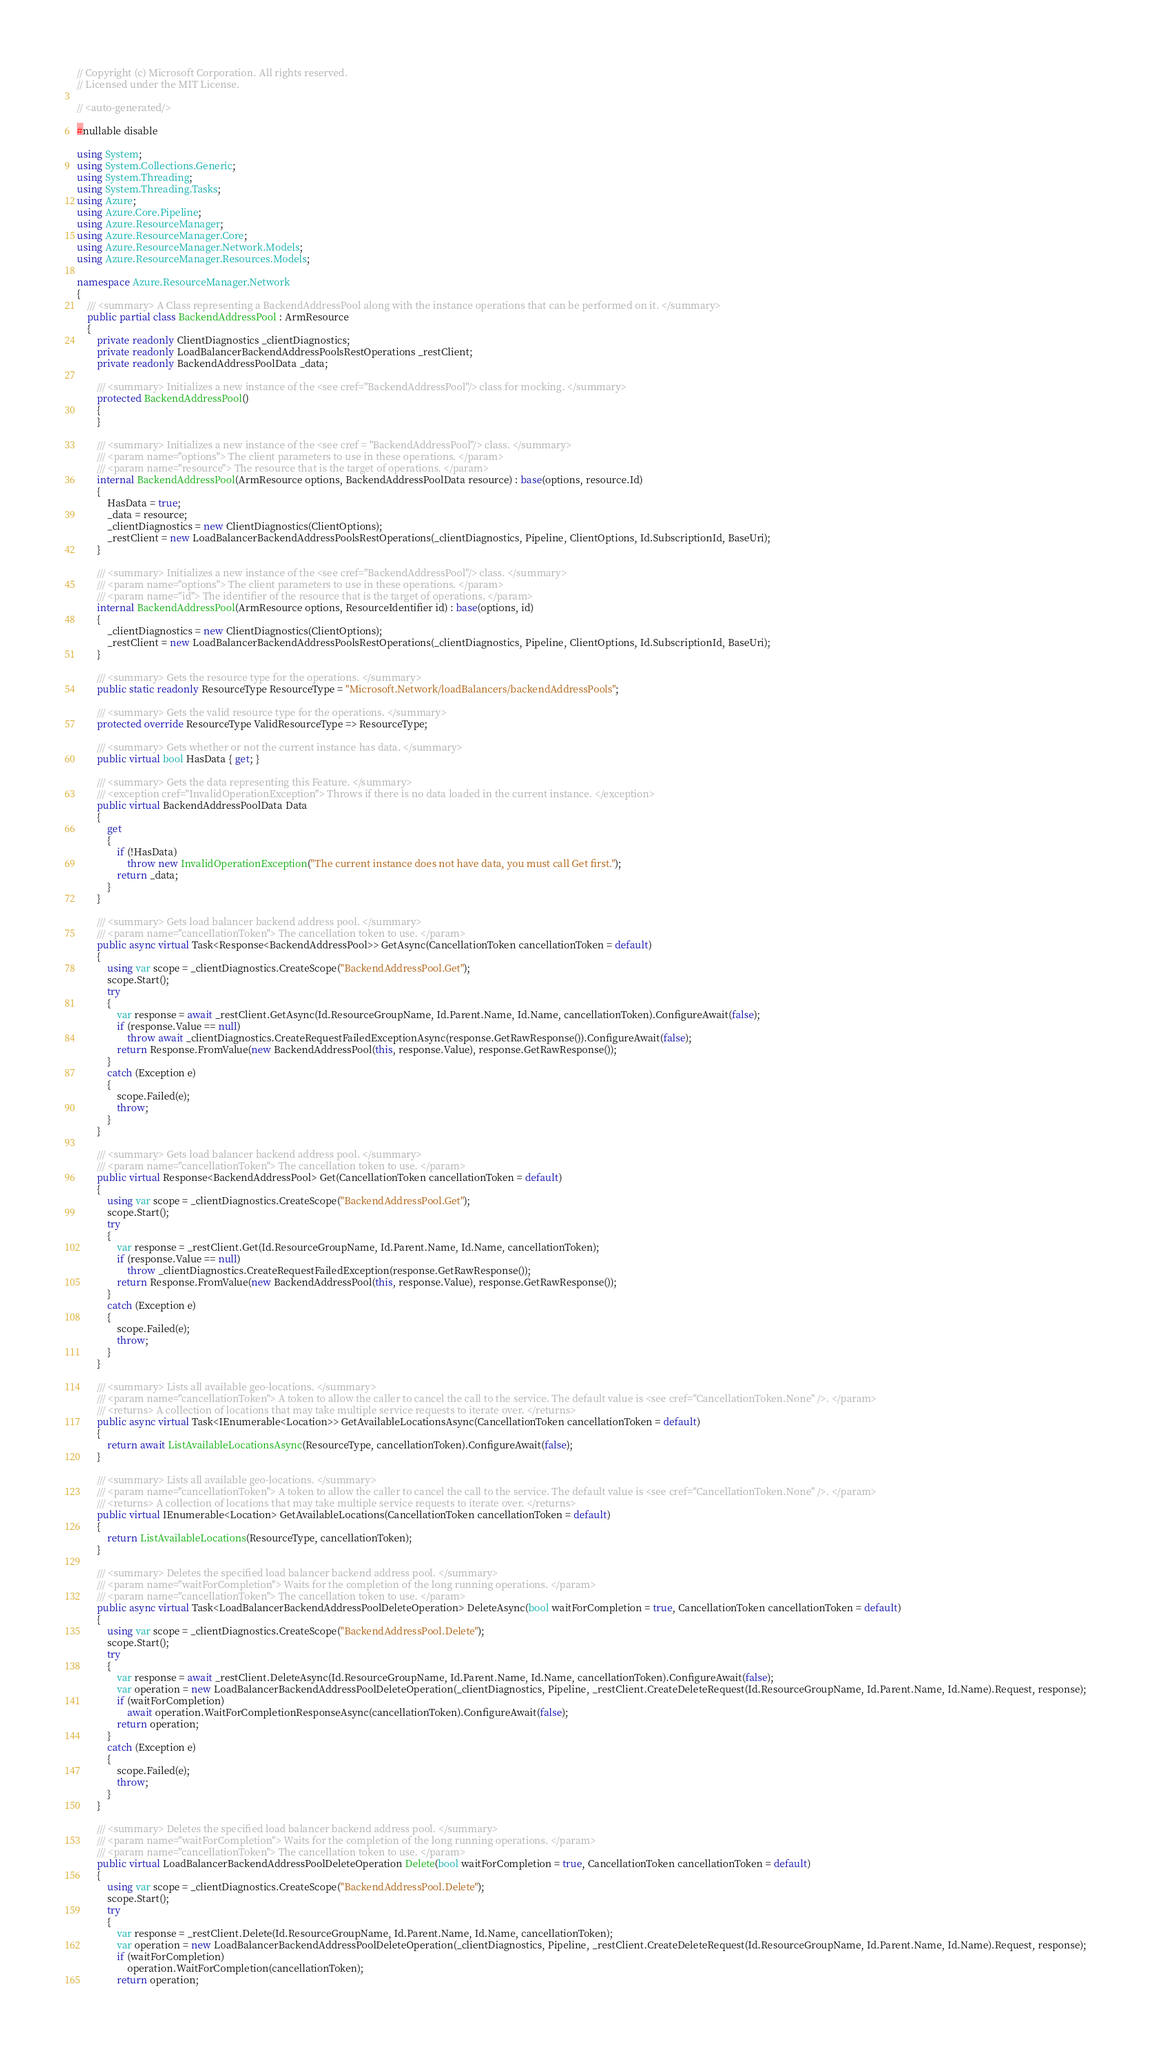Convert code to text. <code><loc_0><loc_0><loc_500><loc_500><_C#_>// Copyright (c) Microsoft Corporation. All rights reserved.
// Licensed under the MIT License.

// <auto-generated/>

#nullable disable

using System;
using System.Collections.Generic;
using System.Threading;
using System.Threading.Tasks;
using Azure;
using Azure.Core.Pipeline;
using Azure.ResourceManager;
using Azure.ResourceManager.Core;
using Azure.ResourceManager.Network.Models;
using Azure.ResourceManager.Resources.Models;

namespace Azure.ResourceManager.Network
{
    /// <summary> A Class representing a BackendAddressPool along with the instance operations that can be performed on it. </summary>
    public partial class BackendAddressPool : ArmResource
    {
        private readonly ClientDiagnostics _clientDiagnostics;
        private readonly LoadBalancerBackendAddressPoolsRestOperations _restClient;
        private readonly BackendAddressPoolData _data;

        /// <summary> Initializes a new instance of the <see cref="BackendAddressPool"/> class for mocking. </summary>
        protected BackendAddressPool()
        {
        }

        /// <summary> Initializes a new instance of the <see cref = "BackendAddressPool"/> class. </summary>
        /// <param name="options"> The client parameters to use in these operations. </param>
        /// <param name="resource"> The resource that is the target of operations. </param>
        internal BackendAddressPool(ArmResource options, BackendAddressPoolData resource) : base(options, resource.Id)
        {
            HasData = true;
            _data = resource;
            _clientDiagnostics = new ClientDiagnostics(ClientOptions);
            _restClient = new LoadBalancerBackendAddressPoolsRestOperations(_clientDiagnostics, Pipeline, ClientOptions, Id.SubscriptionId, BaseUri);
        }

        /// <summary> Initializes a new instance of the <see cref="BackendAddressPool"/> class. </summary>
        /// <param name="options"> The client parameters to use in these operations. </param>
        /// <param name="id"> The identifier of the resource that is the target of operations. </param>
        internal BackendAddressPool(ArmResource options, ResourceIdentifier id) : base(options, id)
        {
            _clientDiagnostics = new ClientDiagnostics(ClientOptions);
            _restClient = new LoadBalancerBackendAddressPoolsRestOperations(_clientDiagnostics, Pipeline, ClientOptions, Id.SubscriptionId, BaseUri);
        }

        /// <summary> Gets the resource type for the operations. </summary>
        public static readonly ResourceType ResourceType = "Microsoft.Network/loadBalancers/backendAddressPools";

        /// <summary> Gets the valid resource type for the operations. </summary>
        protected override ResourceType ValidResourceType => ResourceType;

        /// <summary> Gets whether or not the current instance has data. </summary>
        public virtual bool HasData { get; }

        /// <summary> Gets the data representing this Feature. </summary>
        /// <exception cref="InvalidOperationException"> Throws if there is no data loaded in the current instance. </exception>
        public virtual BackendAddressPoolData Data
        {
            get
            {
                if (!HasData)
                    throw new InvalidOperationException("The current instance does not have data, you must call Get first.");
                return _data;
            }
        }

        /// <summary> Gets load balancer backend address pool. </summary>
        /// <param name="cancellationToken"> The cancellation token to use. </param>
        public async virtual Task<Response<BackendAddressPool>> GetAsync(CancellationToken cancellationToken = default)
        {
            using var scope = _clientDiagnostics.CreateScope("BackendAddressPool.Get");
            scope.Start();
            try
            {
                var response = await _restClient.GetAsync(Id.ResourceGroupName, Id.Parent.Name, Id.Name, cancellationToken).ConfigureAwait(false);
                if (response.Value == null)
                    throw await _clientDiagnostics.CreateRequestFailedExceptionAsync(response.GetRawResponse()).ConfigureAwait(false);
                return Response.FromValue(new BackendAddressPool(this, response.Value), response.GetRawResponse());
            }
            catch (Exception e)
            {
                scope.Failed(e);
                throw;
            }
        }

        /// <summary> Gets load balancer backend address pool. </summary>
        /// <param name="cancellationToken"> The cancellation token to use. </param>
        public virtual Response<BackendAddressPool> Get(CancellationToken cancellationToken = default)
        {
            using var scope = _clientDiagnostics.CreateScope("BackendAddressPool.Get");
            scope.Start();
            try
            {
                var response = _restClient.Get(Id.ResourceGroupName, Id.Parent.Name, Id.Name, cancellationToken);
                if (response.Value == null)
                    throw _clientDiagnostics.CreateRequestFailedException(response.GetRawResponse());
                return Response.FromValue(new BackendAddressPool(this, response.Value), response.GetRawResponse());
            }
            catch (Exception e)
            {
                scope.Failed(e);
                throw;
            }
        }

        /// <summary> Lists all available geo-locations. </summary>
        /// <param name="cancellationToken"> A token to allow the caller to cancel the call to the service. The default value is <see cref="CancellationToken.None" />. </param>
        /// <returns> A collection of locations that may take multiple service requests to iterate over. </returns>
        public async virtual Task<IEnumerable<Location>> GetAvailableLocationsAsync(CancellationToken cancellationToken = default)
        {
            return await ListAvailableLocationsAsync(ResourceType, cancellationToken).ConfigureAwait(false);
        }

        /// <summary> Lists all available geo-locations. </summary>
        /// <param name="cancellationToken"> A token to allow the caller to cancel the call to the service. The default value is <see cref="CancellationToken.None" />. </param>
        /// <returns> A collection of locations that may take multiple service requests to iterate over. </returns>
        public virtual IEnumerable<Location> GetAvailableLocations(CancellationToken cancellationToken = default)
        {
            return ListAvailableLocations(ResourceType, cancellationToken);
        }

        /// <summary> Deletes the specified load balancer backend address pool. </summary>
        /// <param name="waitForCompletion"> Waits for the completion of the long running operations. </param>
        /// <param name="cancellationToken"> The cancellation token to use. </param>
        public async virtual Task<LoadBalancerBackendAddressPoolDeleteOperation> DeleteAsync(bool waitForCompletion = true, CancellationToken cancellationToken = default)
        {
            using var scope = _clientDiagnostics.CreateScope("BackendAddressPool.Delete");
            scope.Start();
            try
            {
                var response = await _restClient.DeleteAsync(Id.ResourceGroupName, Id.Parent.Name, Id.Name, cancellationToken).ConfigureAwait(false);
                var operation = new LoadBalancerBackendAddressPoolDeleteOperation(_clientDiagnostics, Pipeline, _restClient.CreateDeleteRequest(Id.ResourceGroupName, Id.Parent.Name, Id.Name).Request, response);
                if (waitForCompletion)
                    await operation.WaitForCompletionResponseAsync(cancellationToken).ConfigureAwait(false);
                return operation;
            }
            catch (Exception e)
            {
                scope.Failed(e);
                throw;
            }
        }

        /// <summary> Deletes the specified load balancer backend address pool. </summary>
        /// <param name="waitForCompletion"> Waits for the completion of the long running operations. </param>
        /// <param name="cancellationToken"> The cancellation token to use. </param>
        public virtual LoadBalancerBackendAddressPoolDeleteOperation Delete(bool waitForCompletion = true, CancellationToken cancellationToken = default)
        {
            using var scope = _clientDiagnostics.CreateScope("BackendAddressPool.Delete");
            scope.Start();
            try
            {
                var response = _restClient.Delete(Id.ResourceGroupName, Id.Parent.Name, Id.Name, cancellationToken);
                var operation = new LoadBalancerBackendAddressPoolDeleteOperation(_clientDiagnostics, Pipeline, _restClient.CreateDeleteRequest(Id.ResourceGroupName, Id.Parent.Name, Id.Name).Request, response);
                if (waitForCompletion)
                    operation.WaitForCompletion(cancellationToken);
                return operation;</code> 